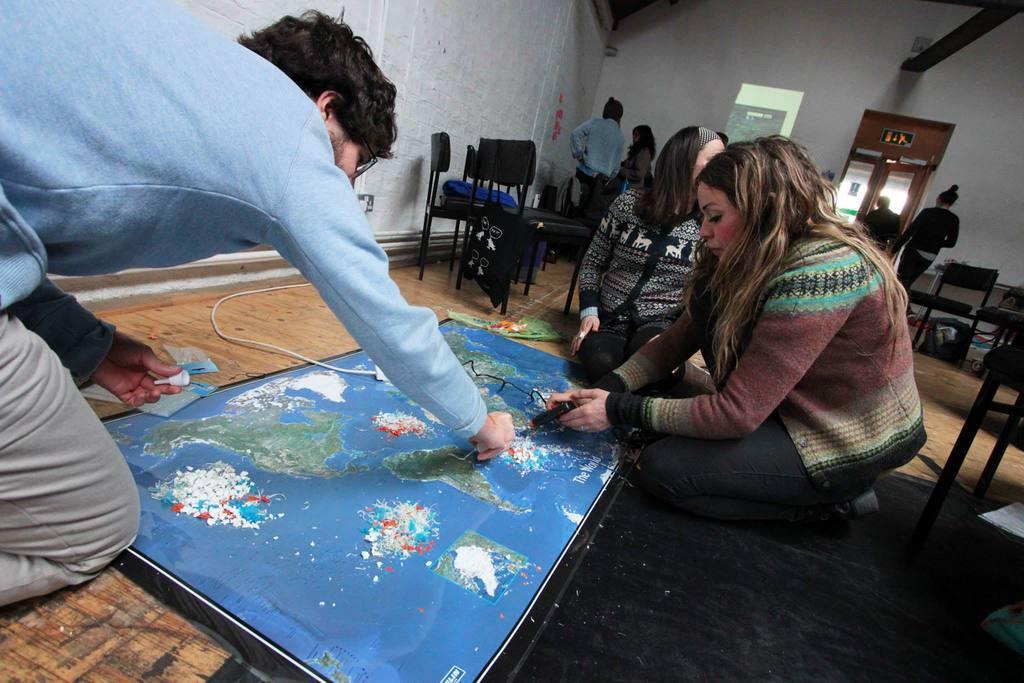In one or two sentences, can you explain what this image depicts? In this image, there are a few people. We can see the ground with some objects. We can see some chairs and posters. We can see the wall and some doors. We can also see an object on the top right corner. 